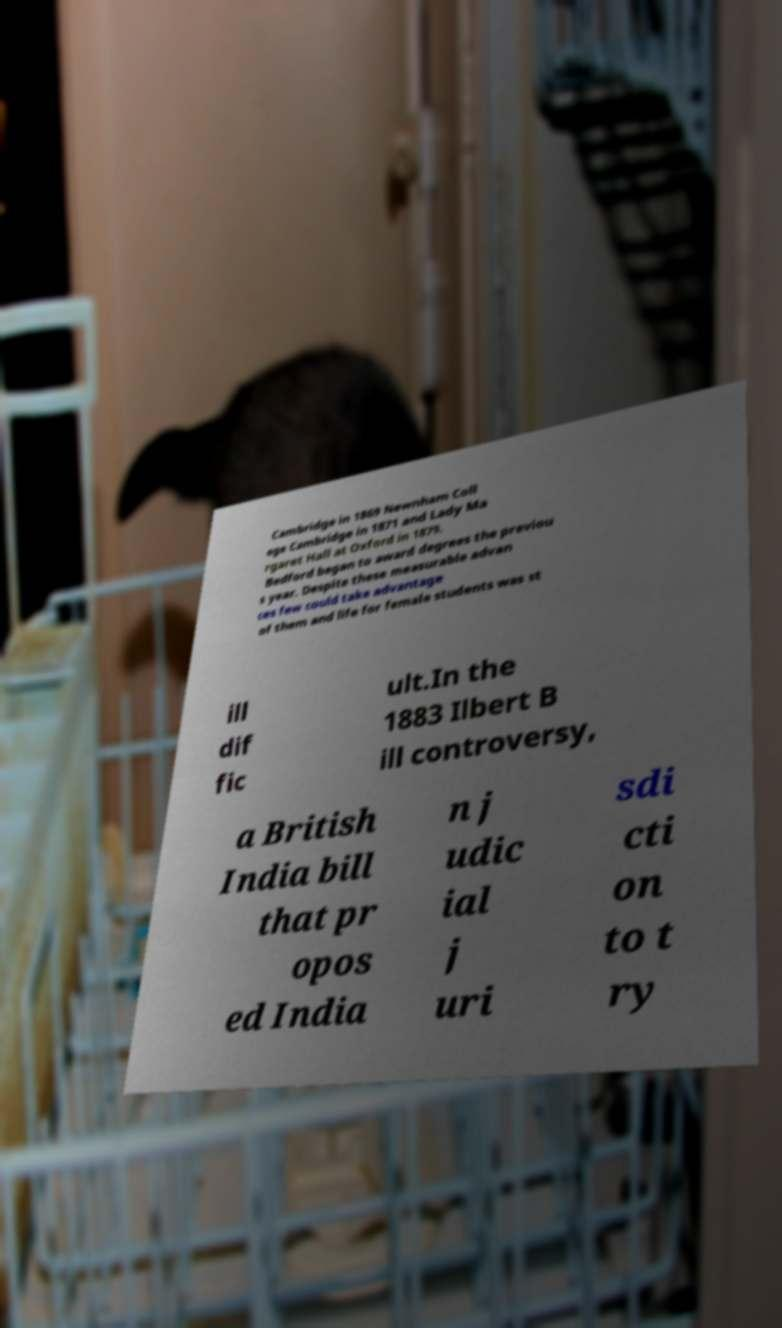Please read and relay the text visible in this image. What does it say? Cambridge in 1869 Newnham Coll ege Cambridge in 1871 and Lady Ma rgaret Hall at Oxford in 1879. Bedford began to award degrees the previou s year. Despite these measurable advan ces few could take advantage of them and life for female students was st ill dif fic ult.In the 1883 Ilbert B ill controversy, a British India bill that pr opos ed India n j udic ial j uri sdi cti on to t ry 